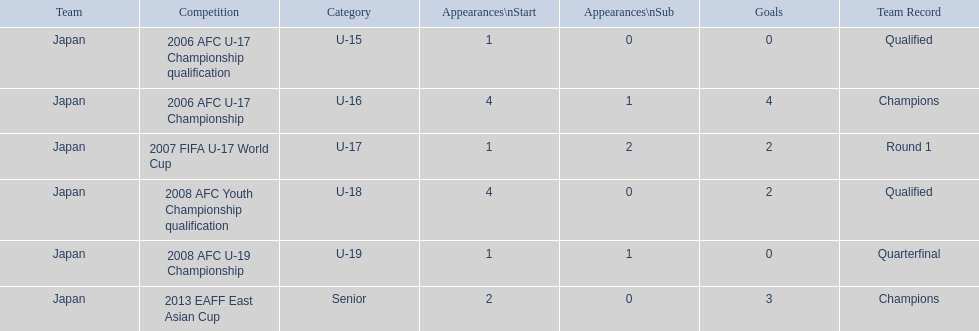What competitions did japan compete in with yoichiro kakitani? 2006 AFC U-17 Championship qualification, 2006 AFC U-17 Championship, 2007 FIFA U-17 World Cup, 2008 AFC Youth Championship qualification, 2008 AFC U-19 Championship, 2013 EAFF East Asian Cup. Of those competitions, which were held in 2007 and 2013? 2007 FIFA U-17 World Cup, 2013 EAFF East Asian Cup. Of the 2007 fifa u-17 world cup and the 2013 eaff east asian cup, which did japan have the most starting appearances? 2013 EAFF East Asian Cup. 